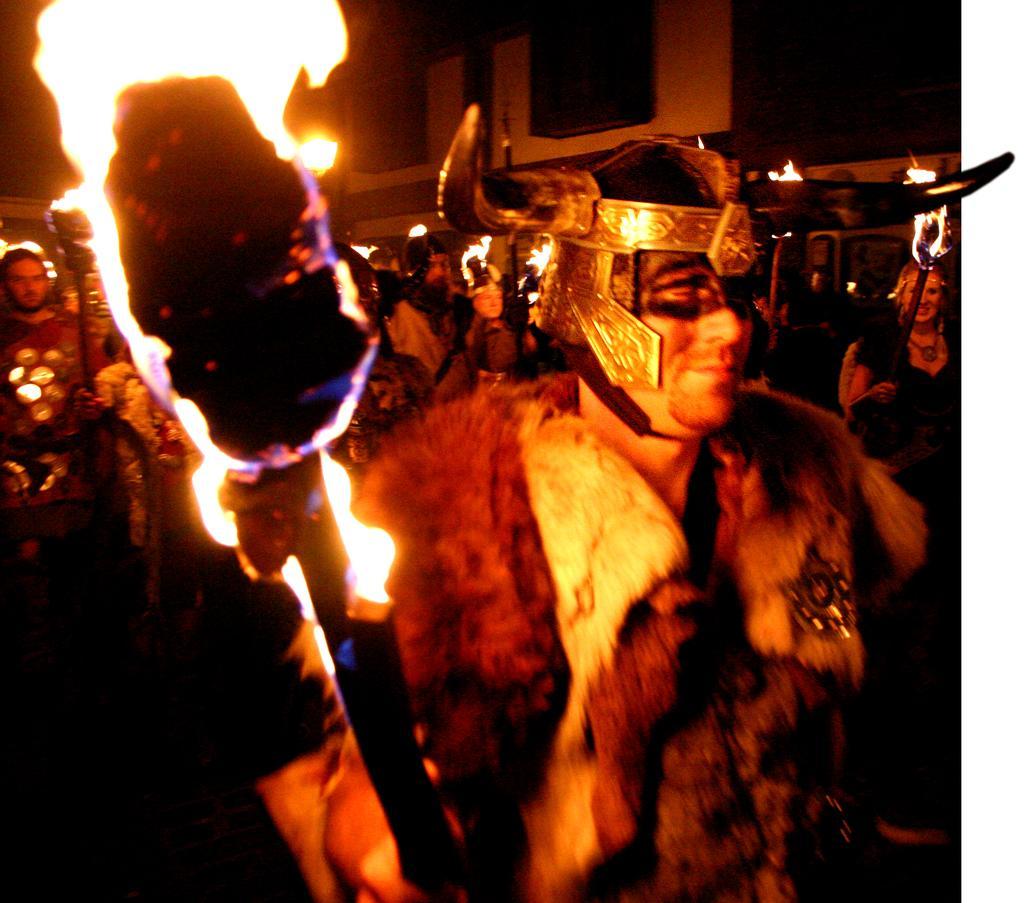Describe this image in one or two sentences. In this picture we can see a group of people, fire sticks and some objects and in the background we can see a building. 